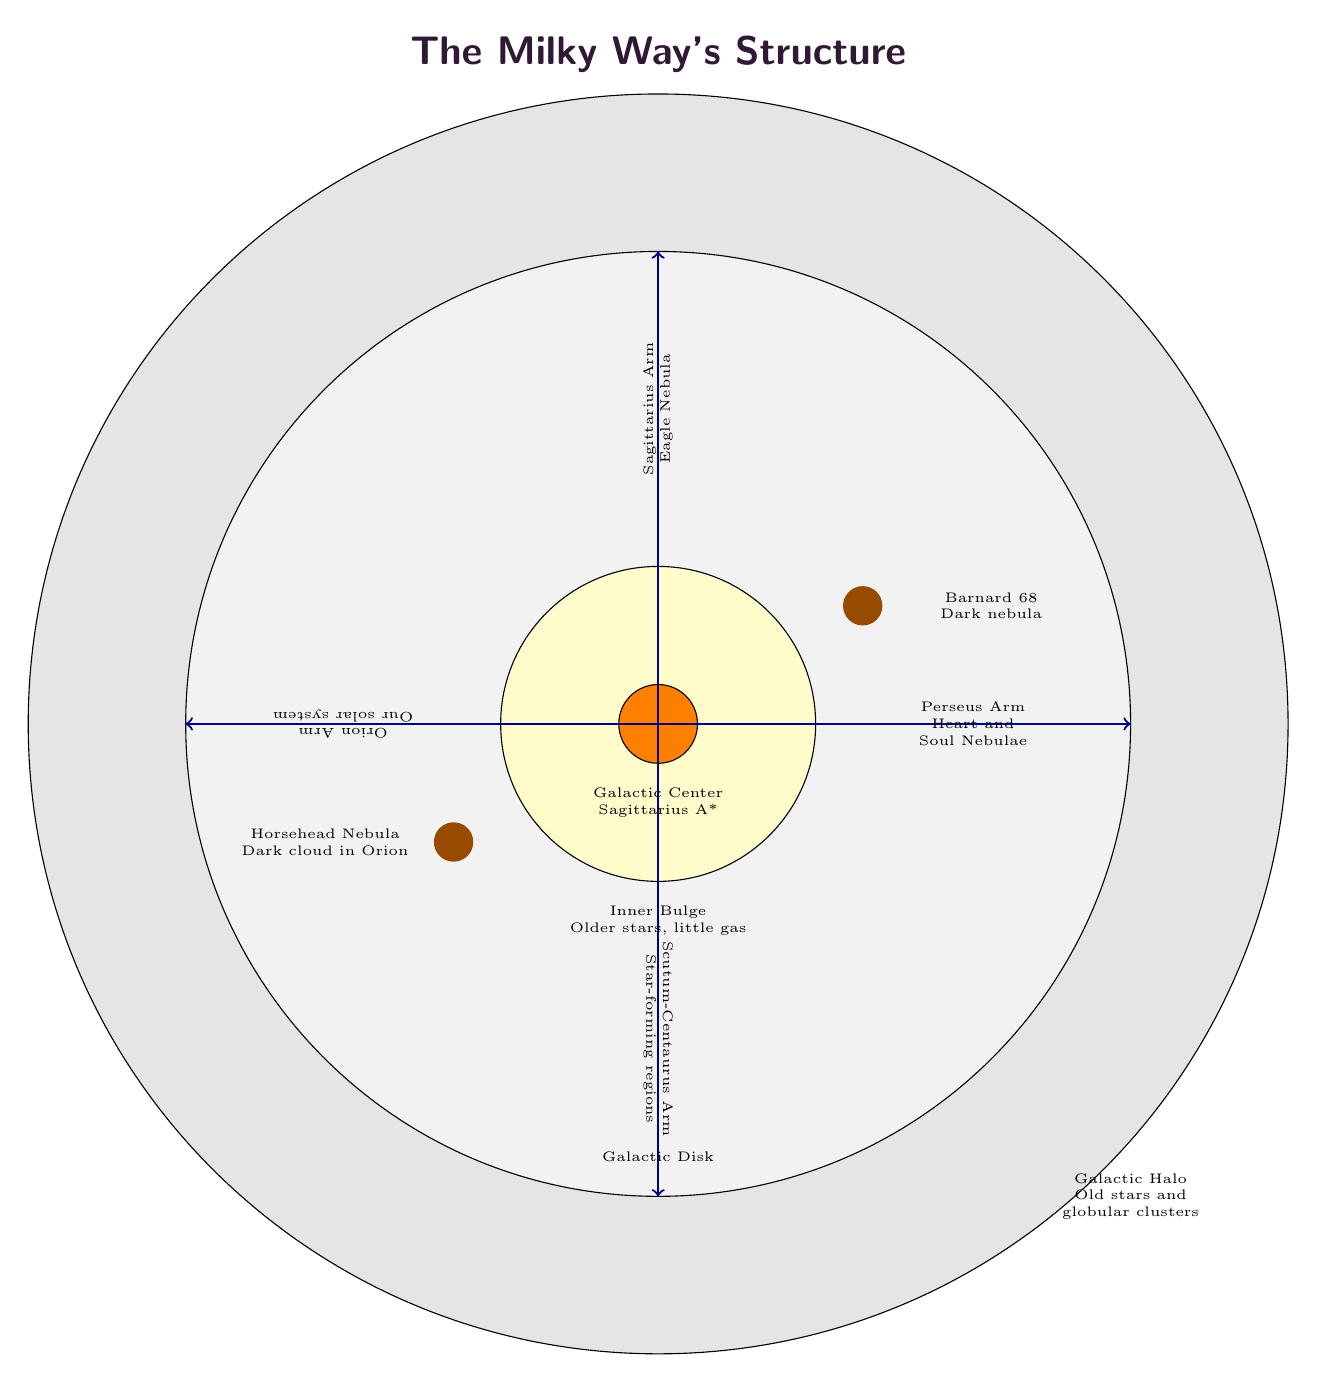What are the names of the spiral arms in the Milky Way? The diagram lists four spiral arms: Perseus Arm, Sagittarius Arm, Orion Arm, and Scutum-Centaurus Arm.
Answer: Perseus Arm, Sagittarius Arm, Orion Arm, Scutum-Centaurus Arm How many dust clouds are labeled in the diagram? The diagram shows two labeled dust clouds: Barnard 68 and Horsehead Nebula. Counting these gives a total of two.
Answer: 2 What is at the center of the Milky Way? The diagram indicates that the Galactic Center contains Sagittarius A*.
Answer: Sagittarius A* Which arm contains our solar system? The diagram notes that the Orion Arm is where our solar system is located.
Answer: Orion Arm What type of stars are primarily found in the inner bulge? According to the diagram, the inner bulge consists of older stars and has little gas.
Answer: Older stars What is the role of the galactic halo? The diagram states that the galactic halo is composed of old stars and globular clusters, indicating a storage of ancient stellar components.
Answer: Old stars and globular clusters Which nebula is associated with the Barnard 68 label? The label associated with Barnard 68 in the diagram specifies it as a dark nebula.
Answer: Dark nebula How far is the outer edge of the galactic disk from the center? The diagram shows that the galactic disk extends 6 cm from the center, indicating the distance from the core to the outer edge.
Answer: 6 cm What color represents the galactic center in the diagram? The galactic center in the diagram is represented by an orange circle.
Answer: Orange 